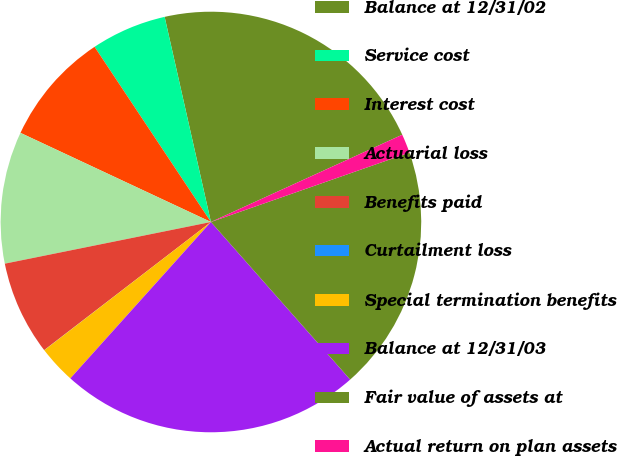Convert chart. <chart><loc_0><loc_0><loc_500><loc_500><pie_chart><fcel>Balance at 12/31/02<fcel>Service cost<fcel>Interest cost<fcel>Actuarial loss<fcel>Benefits paid<fcel>Curtailment loss<fcel>Special termination benefits<fcel>Balance at 12/31/03<fcel>Fair value of assets at<fcel>Actual return on plan assets<nl><fcel>21.72%<fcel>5.8%<fcel>8.7%<fcel>10.14%<fcel>7.25%<fcel>0.01%<fcel>2.91%<fcel>23.17%<fcel>18.83%<fcel>1.46%<nl></chart> 